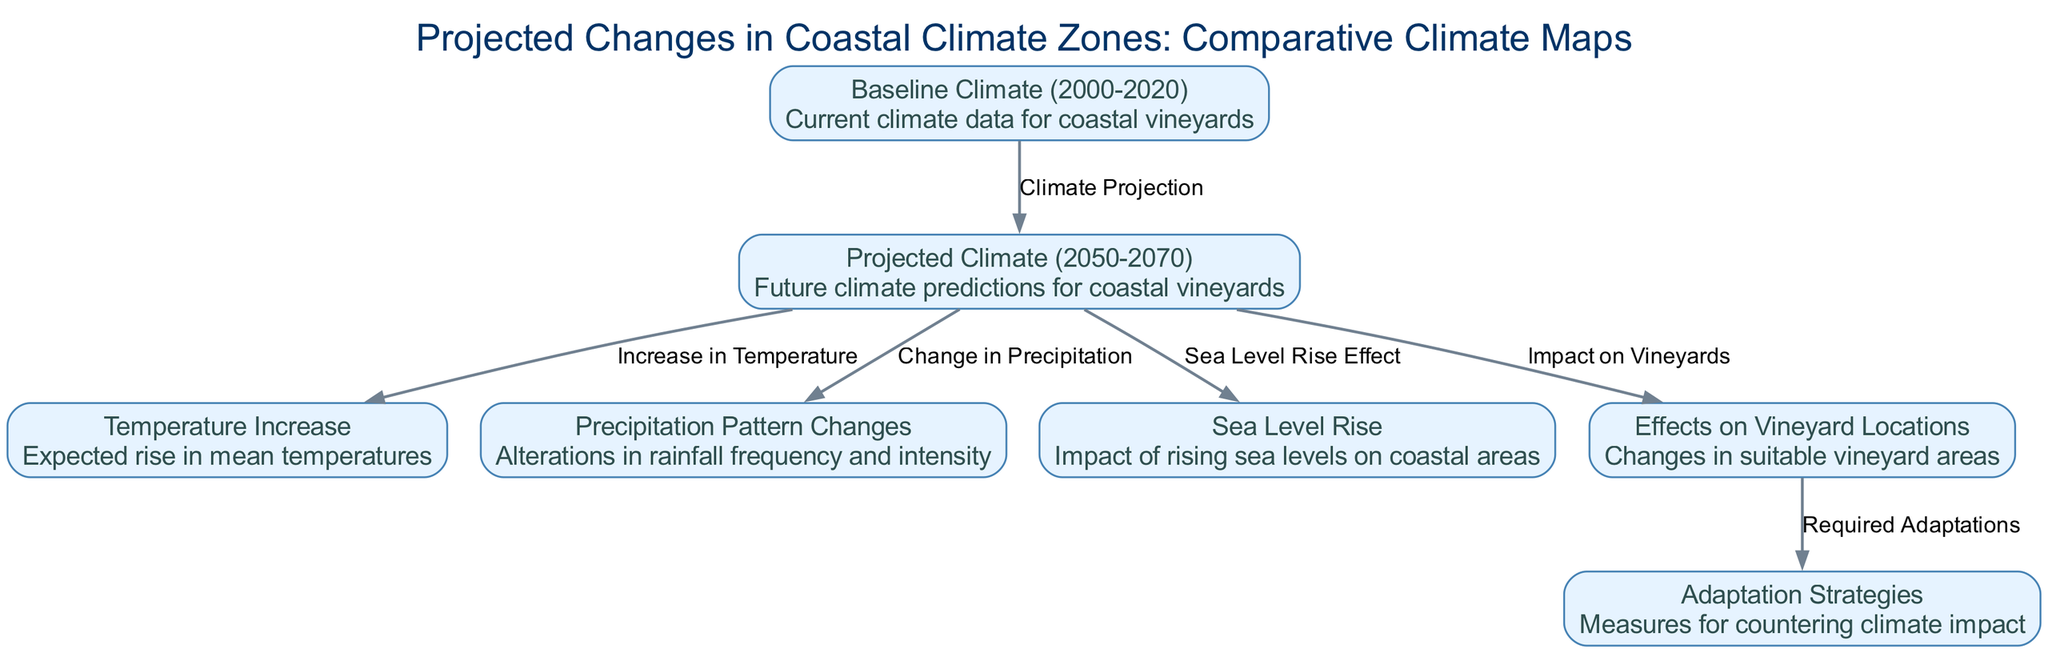What is the title of the diagram? The title of the diagram is found at the top of the visual representation. It provides context for the entire diagram.
Answer: Projected Changes in Coastal Climate Zones: Comparative Climate Maps How many nodes are present in the diagram? By counting the individual elements listed as nodes, we can determine the total. There are six distinct nodes identified in the diagram.
Answer: 7 What is the relationship between Baseline Climate and Projected Climate? The relationship is shown by the directed edge labeled "Climate Projection," connecting the Baseline Climate node to the Projected Climate node.
Answer: Climate Projection What change is expected in mean temperatures by 2050-2070? The diagram indicates an "Expected rise in mean temperatures" as a consequence of the climate projections for 2050-2070.
Answer: Temperature Increase What impact will projected climate have on vineyard locations? The directed edge from Projected Climate to Effects on Vineyard Locations suggests that the climate changes will have an impact on suitable vineyard areas.
Answer: Changes in suitable vineyard areas What is the main adaptation strategy connected to the effects on vineyard locations? The Effects on Vineyard Locations node connects to the Adaptation Strategies node, indicating what actions will be taken to respond to climate change.
Answer: Measures for countering climate impact What do the changes in rainfall frequency and intensity signify in the context of climate projections? The edge labeled "Change in Precipitation" leads from Projected Climate to Precipitation Pattern Changes, signifying that alterations in rainfall will occur due to climate changes.
Answer: Alterations in rainfall frequency and intensity What is the expected effect of sea level rise on coastal areas? The diagram connects Sea Level Rise node to Projected Climate, suggesting that there will be an impact on coastal areas due to rising sea levels as projected for the future.
Answer: Impact of rising sea levels on coastal areas 